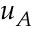Convert formula to latex. <formula><loc_0><loc_0><loc_500><loc_500>u _ { A }</formula> 